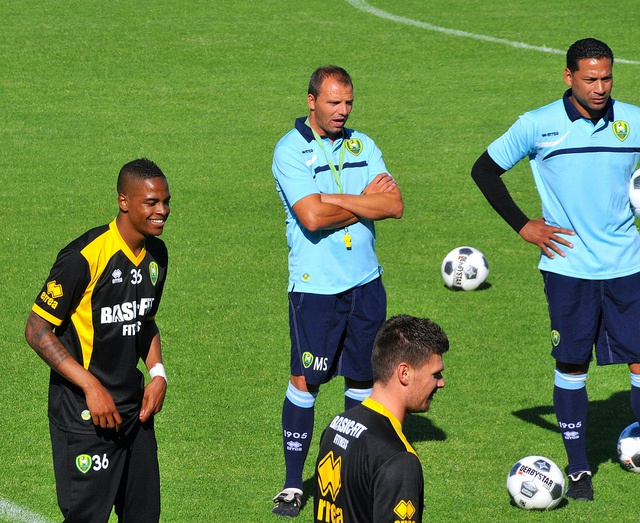Describe the objects in this image and their specific colors. I can see people in olive, lightblue, black, navy, and green tones, people in olive, black, brown, gold, and maroon tones, people in olive, lightblue, black, navy, and salmon tones, people in olive, black, gold, salmon, and maroon tones, and sports ball in olive, white, darkgray, gray, and black tones in this image. 